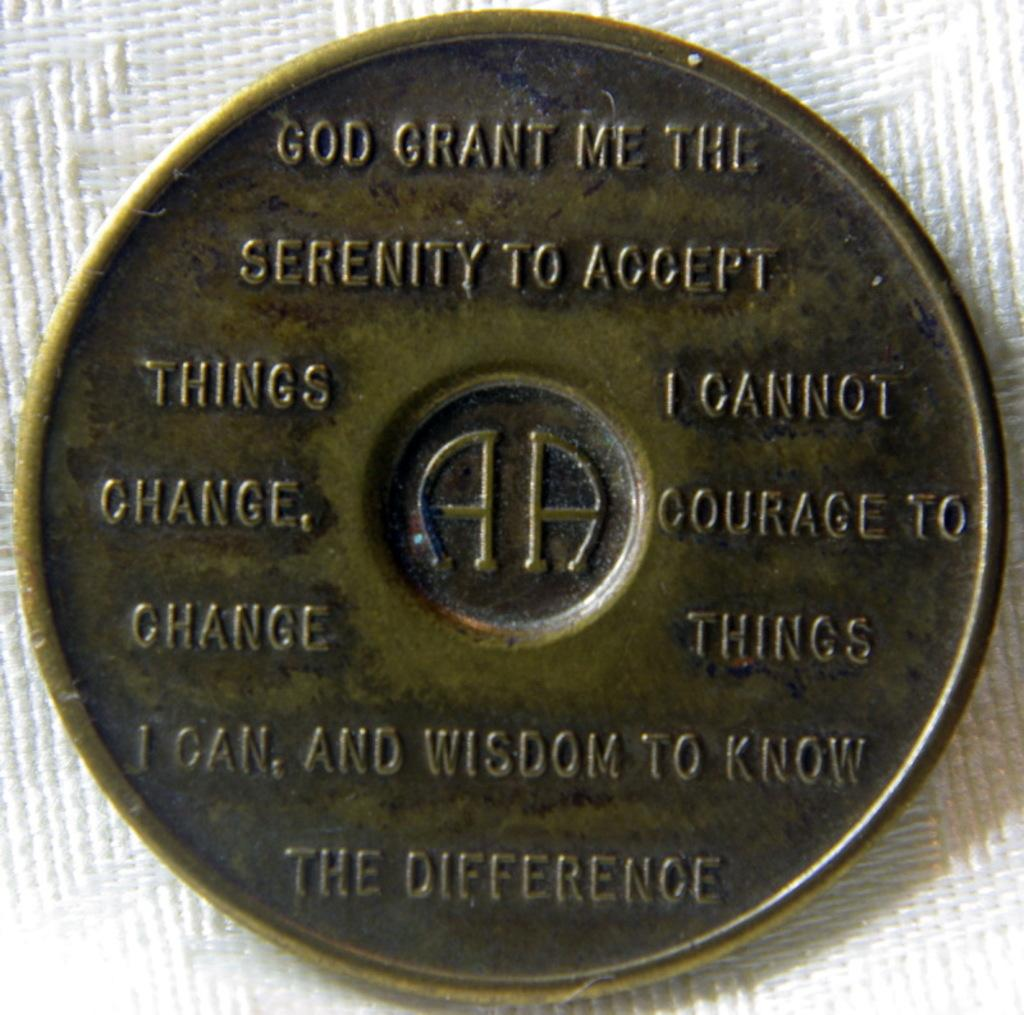<image>
Present a compact description of the photo's key features. a golden coin that says, 'god grant me the serenity to accept things i cannot change, courage to change things i can, and wisdom to know the difference 